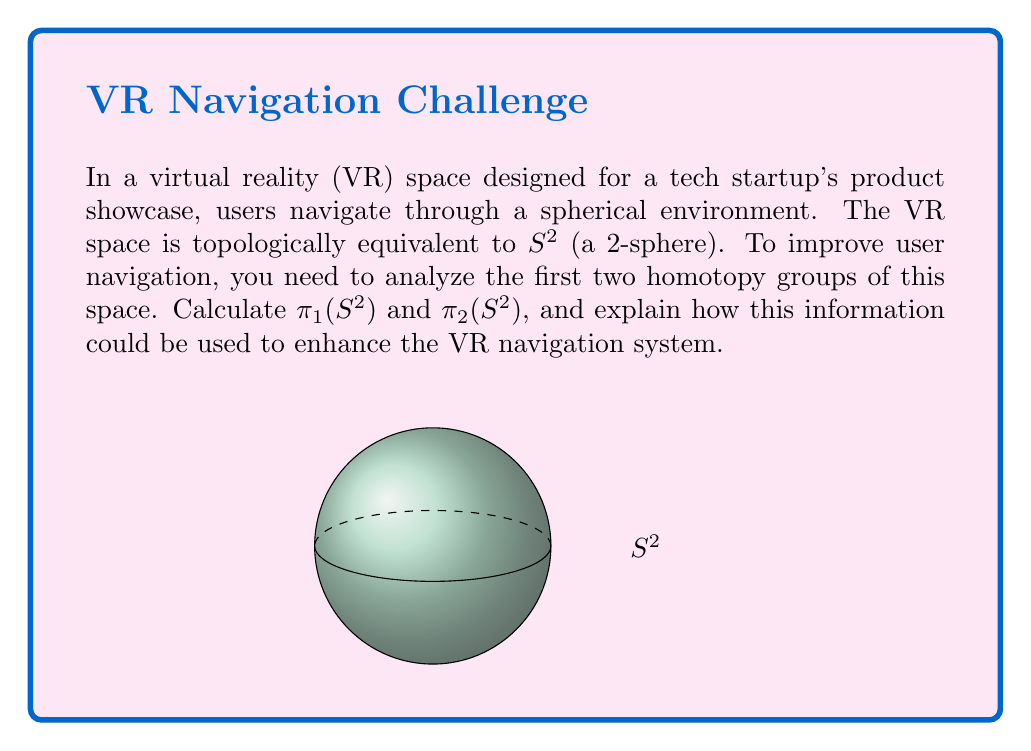Solve this math problem. Let's analyze the homotopy groups step-by-step:

1) First homotopy group $\pi_1(S^2)$:
   - $\pi_1(S^2)$ represents the fundamental group of the 2-sphere.
   - Any loop on the surface of a sphere can be continuously deformed to a point.
   - Therefore, $\pi_1(S^2) = 0$ (the trivial group).

2) Second homotopy group $\pi_2(S^2)$:
   - $\pi_2(S^2)$ represents classes of continuous maps from $S^2$ to $S^2$.
   - The identity map $id: S^2 \to S^2$ cannot be continuously deformed to a constant map.
   - In fact, $\pi_2(S^2) \cong \mathbb{Z}$ (isomorphic to the integers).
   - Each integer corresponds to the winding number of the map.

3) Implications for VR navigation:
   - $\pi_1(S^2) = 0$ implies that any path between two points can be continuously deformed into any other path between those points.
   - This means users can freely navigate on the surface without topological obstructions.
   - $\pi_2(S^2) \cong \mathbb{Z}$ suggests that the entire spherical space can be wrapped around itself in interesting ways.
   - This could be used to create "wormhole" effects or shortcuts in the VR space, allowing users to quickly navigate between distant points.

4) Enhancing VR navigation:
   - Implement a "path smoothing" feature that leverages $\pi_1(S^2) = 0$ to optimize user trajectories.
   - Create "portal" mechanisms based on non-trivial elements of $\pi_2(S^2)$ to enable rapid long-distance movement.
   - Design a multi-layered navigation system where each layer corresponds to a different winding number in $\pi_2(S^2)$.
Answer: $\pi_1(S^2) = 0$, $\pi_2(S^2) \cong \mathbb{Z}$. Use for path smoothing and wormhole-like shortcuts. 